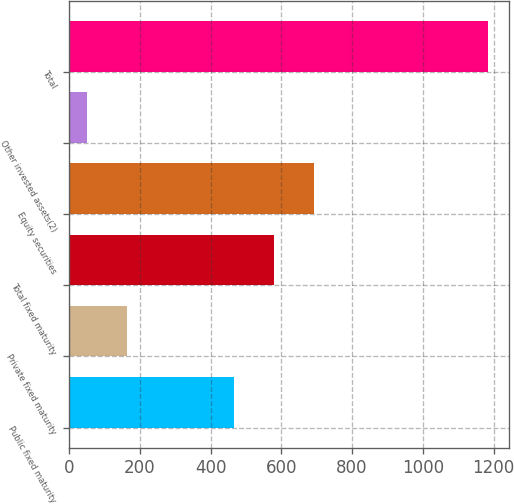<chart> <loc_0><loc_0><loc_500><loc_500><bar_chart><fcel>Public fixed maturity<fcel>Private fixed maturity<fcel>Total fixed maturity<fcel>Equity securities<fcel>Other invested assets(2)<fcel>Total<nl><fcel>465<fcel>164.3<fcel>578.3<fcel>691.6<fcel>51<fcel>1184<nl></chart> 